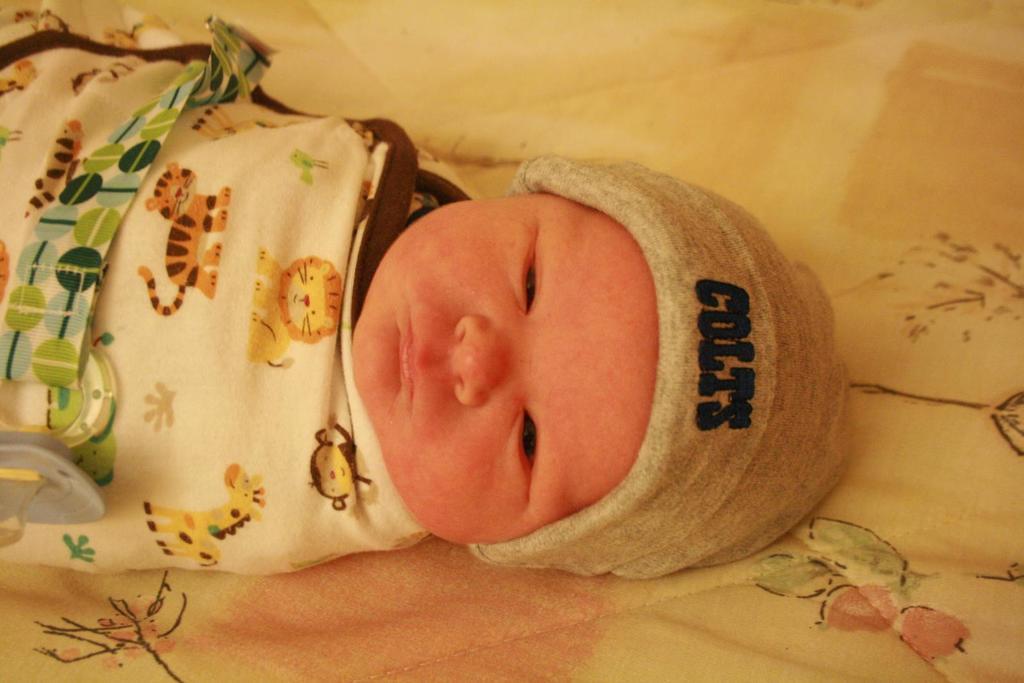Could you give a brief overview of what you see in this image? In this image we can see a baby on the bed. There is a cap on the head. 